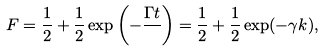Convert formula to latex. <formula><loc_0><loc_0><loc_500><loc_500>F = \frac { 1 } { 2 } + \frac { 1 } { 2 } \exp { \left ( - \frac { \Gamma t } { } \right ) } = \frac { 1 } { 2 } + \frac { 1 } { 2 } \exp ( - \gamma k ) ,</formula> 